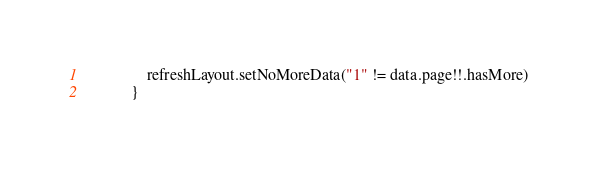<code> <loc_0><loc_0><loc_500><loc_500><_Kotlin_>                refreshLayout.setNoMoreData("1" != data.page!!.hasMore)
            }
</code> 